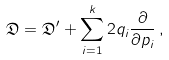Convert formula to latex. <formula><loc_0><loc_0><loc_500><loc_500>\mathfrak { D } = \mathfrak { D } ^ { \prime } + \sum _ { i = 1 } ^ { k } 2 q _ { i } \frac { \partial } { \partial p _ { i } } \, ,</formula> 